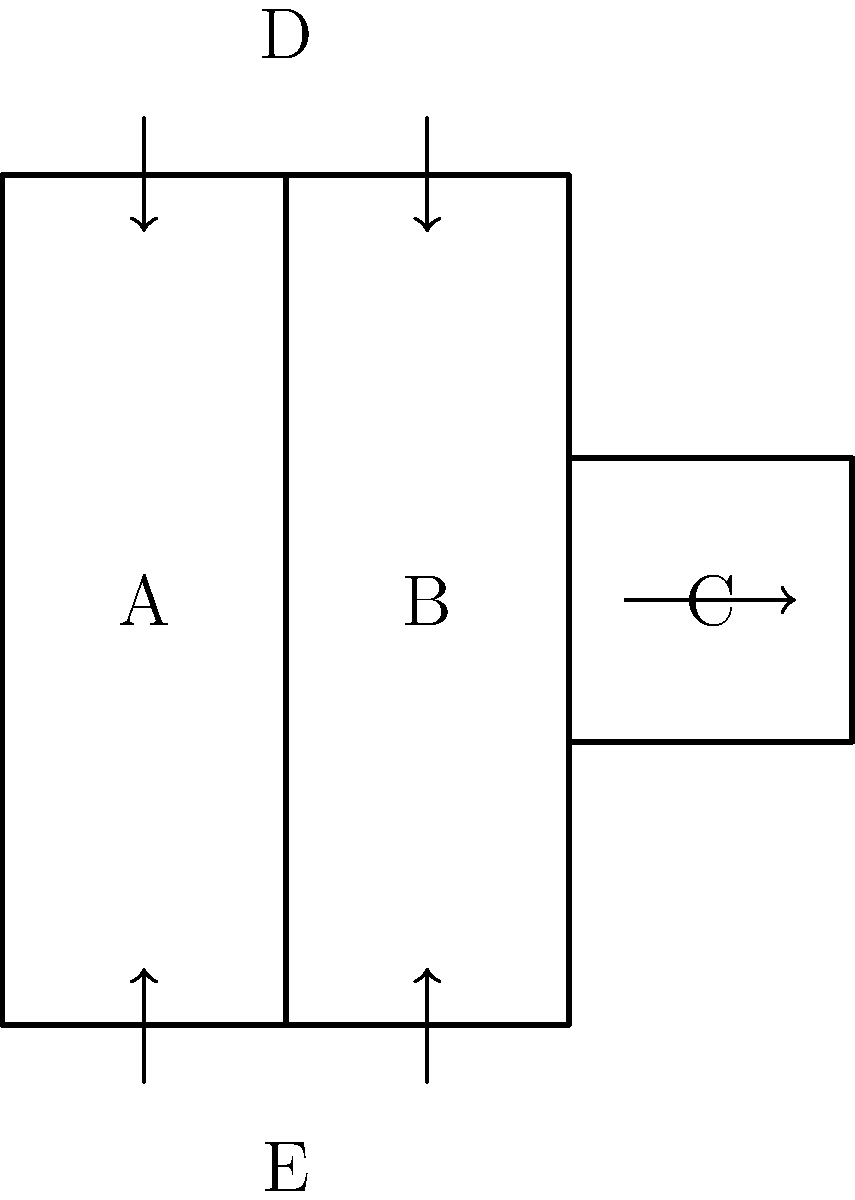As a historian specializing in retail businesses, you've come across an unfolded pattern for a vintage product packaging design from the 1950s. The diagram shows the flat layout of a rectangular box with labeled sides A, B, C, D, and E. Which side will be opposite to side B when the box is folded? To determine which side will be opposite to side B when the box is folded, let's follow these steps:

1. Identify the main body of the box:
   - Side B is the central panel.
   - Sides A and C are attached to the left and right of B, respectively.

2. Understand the folding process:
   - The arrows indicate that sides D and E fold upward and downward, respectively.
   - Side C folds to the right.

3. Visualize the 3D structure:
   - Sides A, B, and C will form three sides of the rectangular box.
   - Side D will form the top of the box.
   - Side E will form the bottom of the box.

4. Determine the opposite side:
   - In a rectangular box, the side opposite to the front (B) would be the back.
   - The only remaining side that could serve as the back is side C.

Therefore, when the box is folded, side C will be directly opposite to side B.
Answer: C 